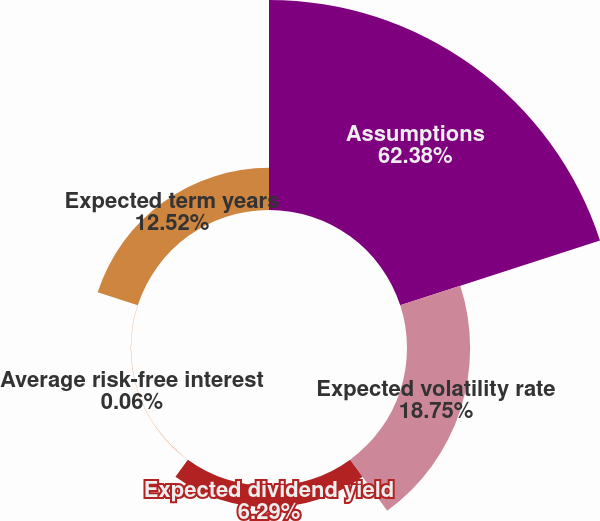Convert chart. <chart><loc_0><loc_0><loc_500><loc_500><pie_chart><fcel>Assumptions<fcel>Expected volatility rate<fcel>Expected dividend yield<fcel>Average risk-free interest<fcel>Expected term years<nl><fcel>62.37%<fcel>18.75%<fcel>6.29%<fcel>0.06%<fcel>12.52%<nl></chart> 